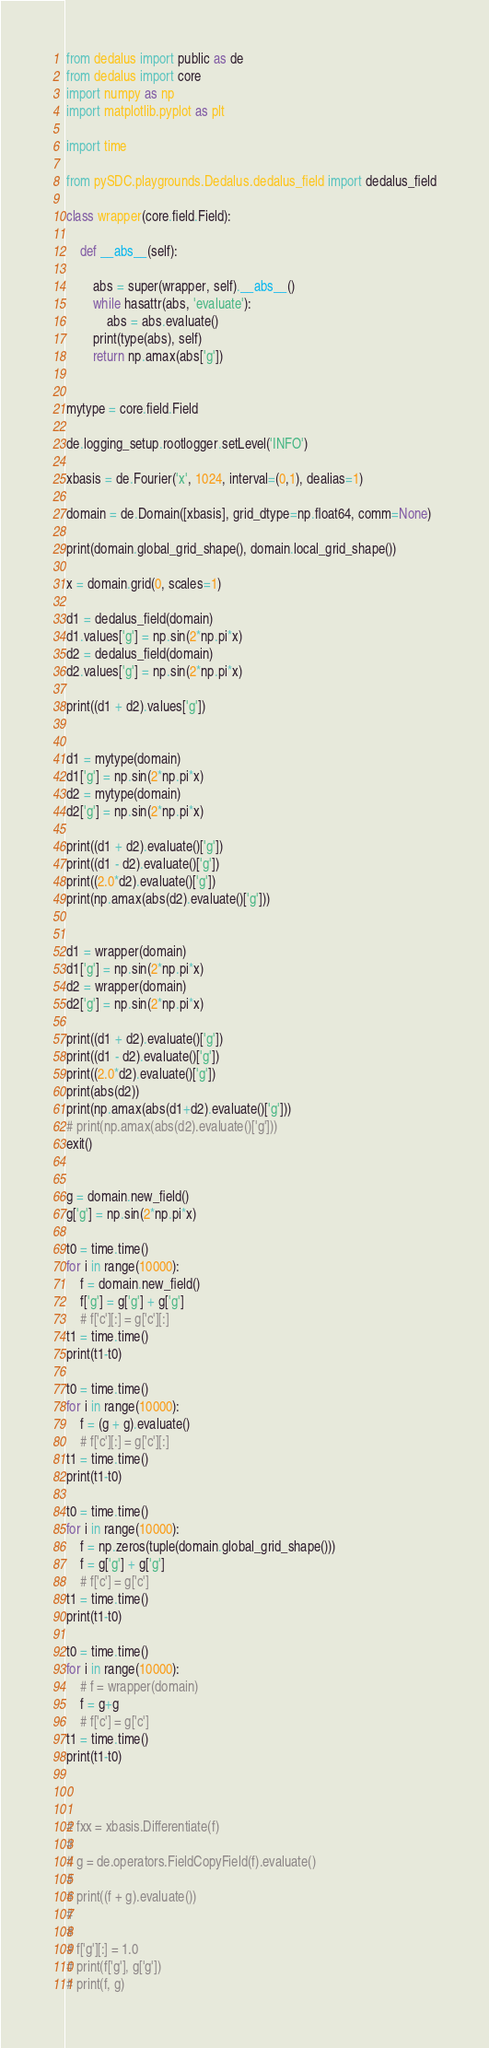<code> <loc_0><loc_0><loc_500><loc_500><_Python_>
from dedalus import public as de
from dedalus import core
import numpy as np
import matplotlib.pyplot as plt

import time

from pySDC.playgrounds.Dedalus.dedalus_field import dedalus_field

class wrapper(core.field.Field):

    def __abs__(self):

        abs = super(wrapper, self).__abs__()
        while hasattr(abs, 'evaluate'):
            abs = abs.evaluate()
        print(type(abs), self)
        return np.amax(abs['g'])


mytype = core.field.Field

de.logging_setup.rootlogger.setLevel('INFO')

xbasis = de.Fourier('x', 1024, interval=(0,1), dealias=1)

domain = de.Domain([xbasis], grid_dtype=np.float64, comm=None)

print(domain.global_grid_shape(), domain.local_grid_shape())

x = domain.grid(0, scales=1)

d1 = dedalus_field(domain)
d1.values['g'] = np.sin(2*np.pi*x)
d2 = dedalus_field(domain)
d2.values['g'] = np.sin(2*np.pi*x)

print((d1 + d2).values['g'])


d1 = mytype(domain)
d1['g'] = np.sin(2*np.pi*x)
d2 = mytype(domain)
d2['g'] = np.sin(2*np.pi*x)

print((d1 + d2).evaluate()['g'])
print((d1 - d2).evaluate()['g'])
print((2.0*d2).evaluate()['g'])
print(np.amax(abs(d2).evaluate()['g']))


d1 = wrapper(domain)
d1['g'] = np.sin(2*np.pi*x)
d2 = wrapper(domain)
d2['g'] = np.sin(2*np.pi*x)

print((d1 + d2).evaluate()['g'])
print((d1 - d2).evaluate()['g'])
print((2.0*d2).evaluate()['g'])
print(abs(d2))
print(np.amax(abs(d1+d2).evaluate()['g']))
# print(np.amax(abs(d2).evaluate()['g']))
exit()


g = domain.new_field()
g['g'] = np.sin(2*np.pi*x)

t0 = time.time()
for i in range(10000):
    f = domain.new_field()
    f['g'] = g['g'] + g['g']
    # f['c'][:] = g['c'][:]
t1 = time.time()
print(t1-t0)

t0 = time.time()
for i in range(10000):
    f = (g + g).evaluate()
    # f['c'][:] = g['c'][:]
t1 = time.time()
print(t1-t0)

t0 = time.time()
for i in range(10000):
    f = np.zeros(tuple(domain.global_grid_shape()))
    f = g['g'] + g['g']
    # f['c'] = g['c']
t1 = time.time()
print(t1-t0)

t0 = time.time()
for i in range(10000):
    # f = wrapper(domain)
    f = g+g
    # f['c'] = g['c']
t1 = time.time()
print(t1-t0)



# fxx = xbasis.Differentiate(f)
#
# g = de.operators.FieldCopyField(f).evaluate()
#
# print((f + g).evaluate())
#
#
# f['g'][:] = 1.0
# print(f['g'], g['g'])
# print(f, g)





</code> 